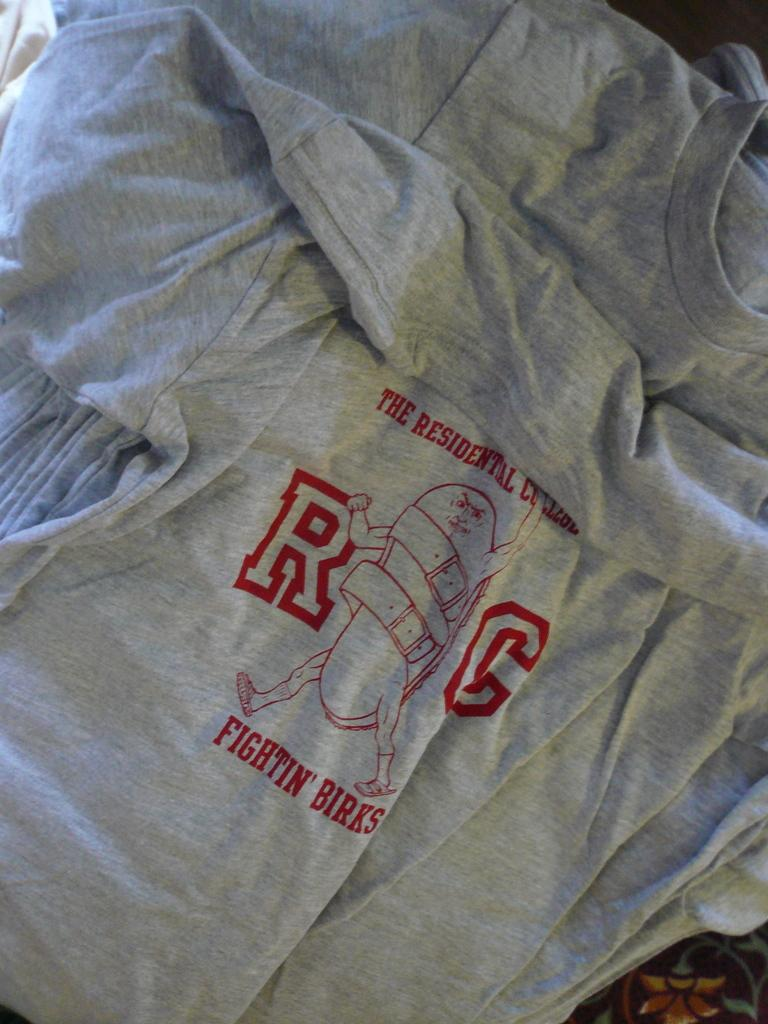<image>
Provide a brief description of the given image. A grey shirt with red font that reads RG, Fightin' Birks. 